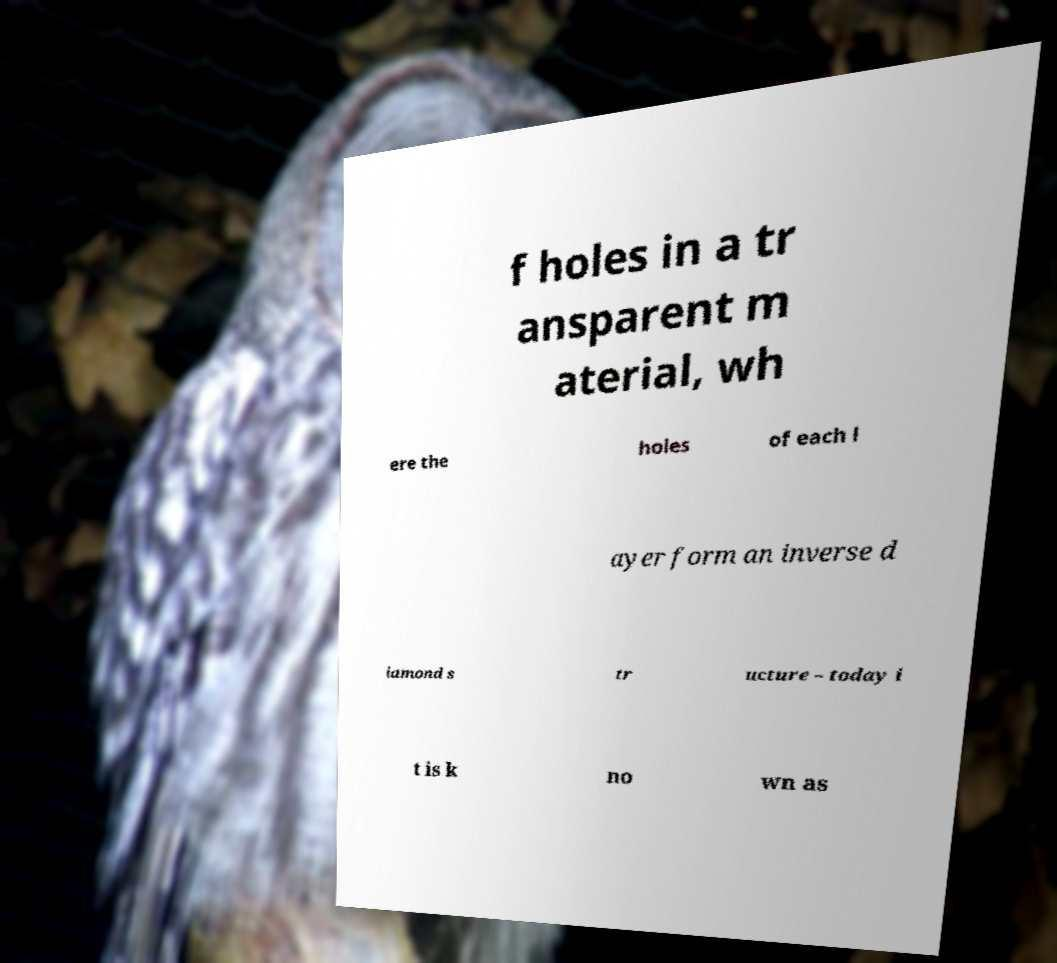Can you accurately transcribe the text from the provided image for me? f holes in a tr ansparent m aterial, wh ere the holes of each l ayer form an inverse d iamond s tr ucture – today i t is k no wn as 